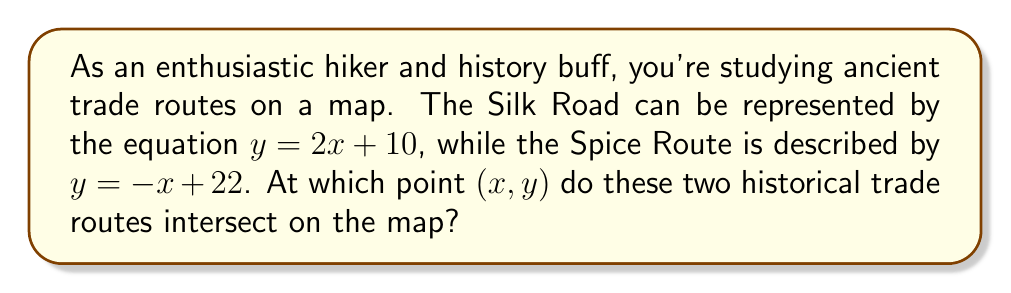Can you answer this question? To find the intersection point of these two trade routes, we need to solve the system of linear equations:

1) First, let's write out our system of equations:
   $$y = 2x + 10$$ (Silk Road)
   $$y = -x + 22$$ (Spice Route)

2) At the intersection point, the y-coordinates will be equal. So we can set the right sides of these equations equal to each other:
   $$2x + 10 = -x + 22$$

3) Now, let's solve this equation for x:
   $$2x + 10 = -x + 22$$
   $$3x + 10 = 22$$
   $$3x = 12$$
   $$x = 4$$

4) Now that we know the x-coordinate of the intersection point, we can substitute this value into either of our original equations to find the y-coordinate. Let's use the Silk Road equation:
   $$y = 2x + 10$$
   $$y = 2(4) + 10$$
   $$y = 8 + 10 = 18$$

5) Therefore, the intersection point is (4, 18).
Answer: (4, 18) 